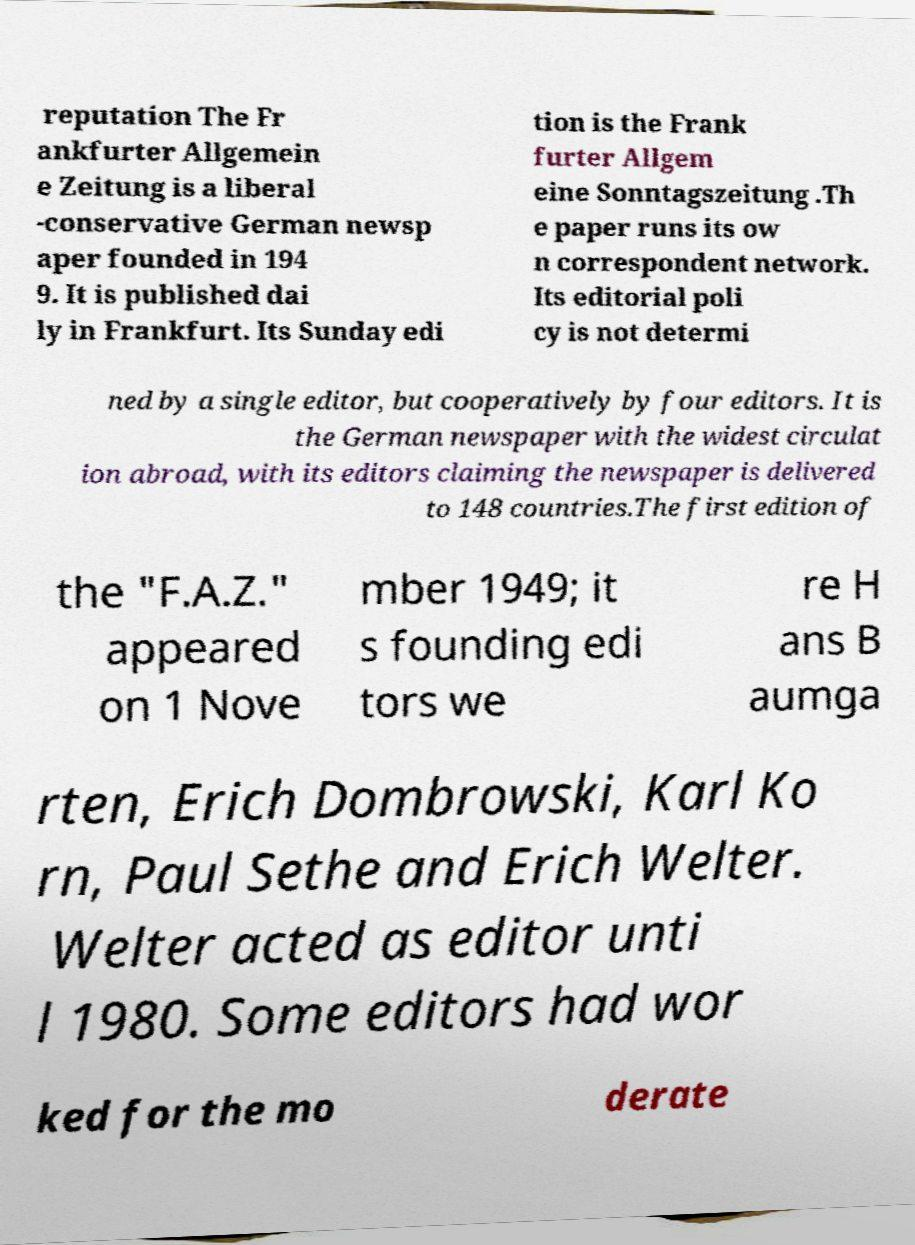Can you accurately transcribe the text from the provided image for me? reputation The Fr ankfurter Allgemein e Zeitung is a liberal -conservative German newsp aper founded in 194 9. It is published dai ly in Frankfurt. Its Sunday edi tion is the Frank furter Allgem eine Sonntagszeitung .Th e paper runs its ow n correspondent network. Its editorial poli cy is not determi ned by a single editor, but cooperatively by four editors. It is the German newspaper with the widest circulat ion abroad, with its editors claiming the newspaper is delivered to 148 countries.The first edition of the "F.A.Z." appeared on 1 Nove mber 1949; it s founding edi tors we re H ans B aumga rten, Erich Dombrowski, Karl Ko rn, Paul Sethe and Erich Welter. Welter acted as editor unti l 1980. Some editors had wor ked for the mo derate 